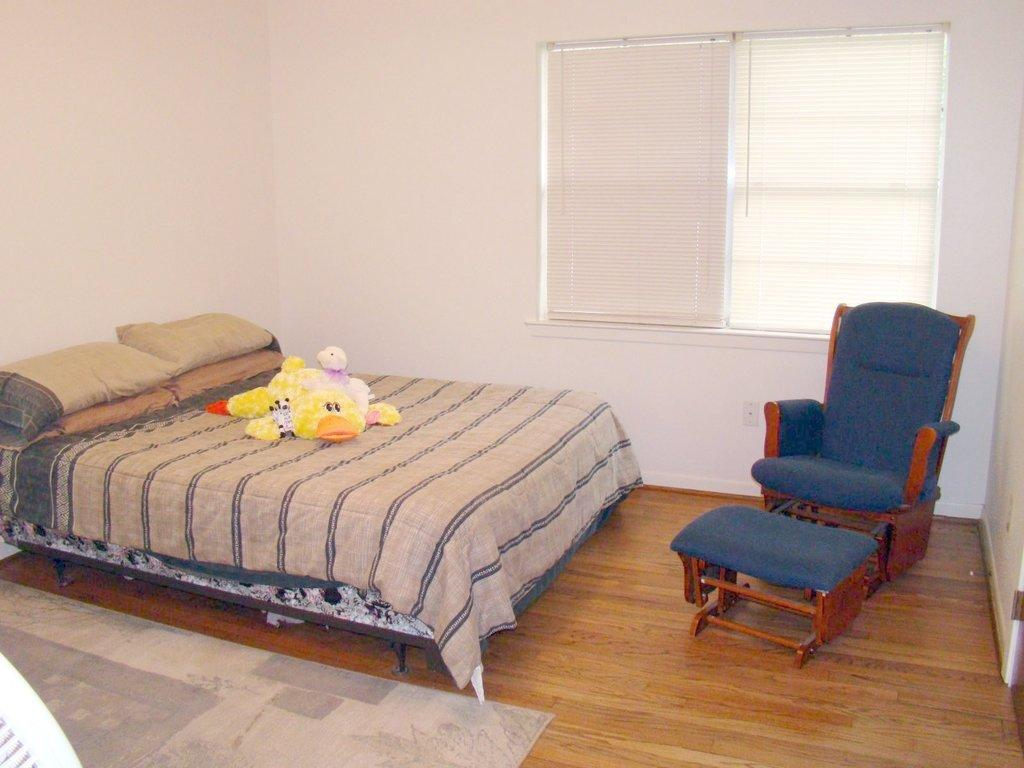What type of room is depicted in the image? The image shows the inner view of a room. What furniture is present in the room? There is a cot, a couch, and a side table in the room. What is placed on the cot? There is a quilt on the cot, and there are pillows in the room. What is on the floor of the room? There is a carpet on the floor. What type of window treatment is present in the room? There are blinds in the room. Are there any decorative items in the room? Yes, there are soft toys in the room. Can you see any boats in the harbor from the room in the image? There is no harbor or boats visible in the image; it shows an indoor room with various furniture and items. 